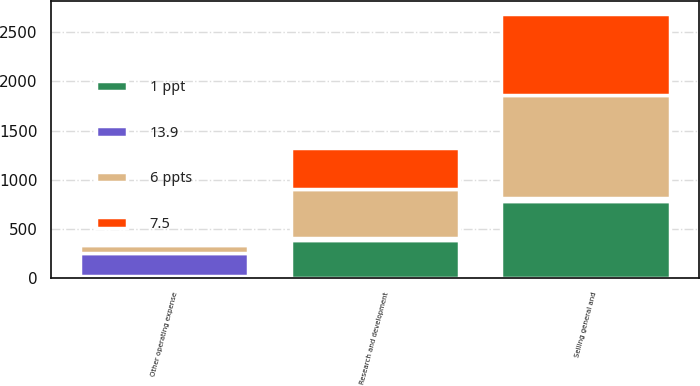<chart> <loc_0><loc_0><loc_500><loc_500><stacked_bar_chart><ecel><fcel>Research and development<fcel>Selling general and<fcel>Other operating expense<nl><fcel>6 ppts<fcel>498<fcel>1049<fcel>84<nl><fcel>7.5<fcel>425<fcel>818<fcel>25<nl><fcel>1 ppt<fcel>387<fcel>787<fcel>18<nl><fcel>13.9<fcel>17<fcel>28<fcel>237<nl></chart> 